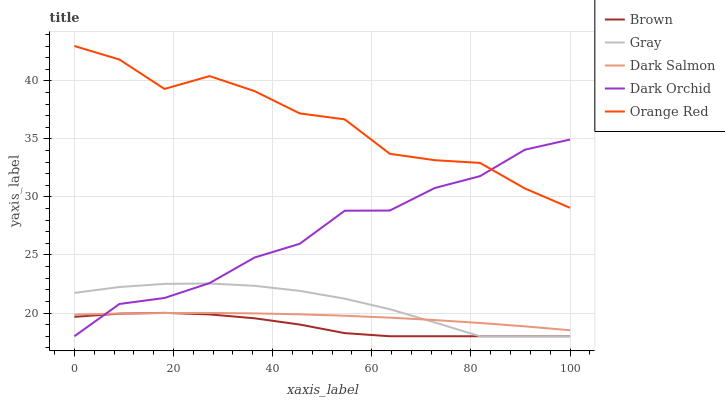Does Brown have the minimum area under the curve?
Answer yes or no. Yes. Does Orange Red have the maximum area under the curve?
Answer yes or no. Yes. Does Dark Salmon have the minimum area under the curve?
Answer yes or no. No. Does Dark Salmon have the maximum area under the curve?
Answer yes or no. No. Is Dark Salmon the smoothest?
Answer yes or no. Yes. Is Orange Red the roughest?
Answer yes or no. Yes. Is Orange Red the smoothest?
Answer yes or no. No. Is Dark Salmon the roughest?
Answer yes or no. No. Does Brown have the lowest value?
Answer yes or no. Yes. Does Dark Salmon have the lowest value?
Answer yes or no. No. Does Orange Red have the highest value?
Answer yes or no. Yes. Does Dark Salmon have the highest value?
Answer yes or no. No. Is Brown less than Orange Red?
Answer yes or no. Yes. Is Orange Red greater than Dark Salmon?
Answer yes or no. Yes. Does Dark Salmon intersect Brown?
Answer yes or no. Yes. Is Dark Salmon less than Brown?
Answer yes or no. No. Is Dark Salmon greater than Brown?
Answer yes or no. No. Does Brown intersect Orange Red?
Answer yes or no. No. 